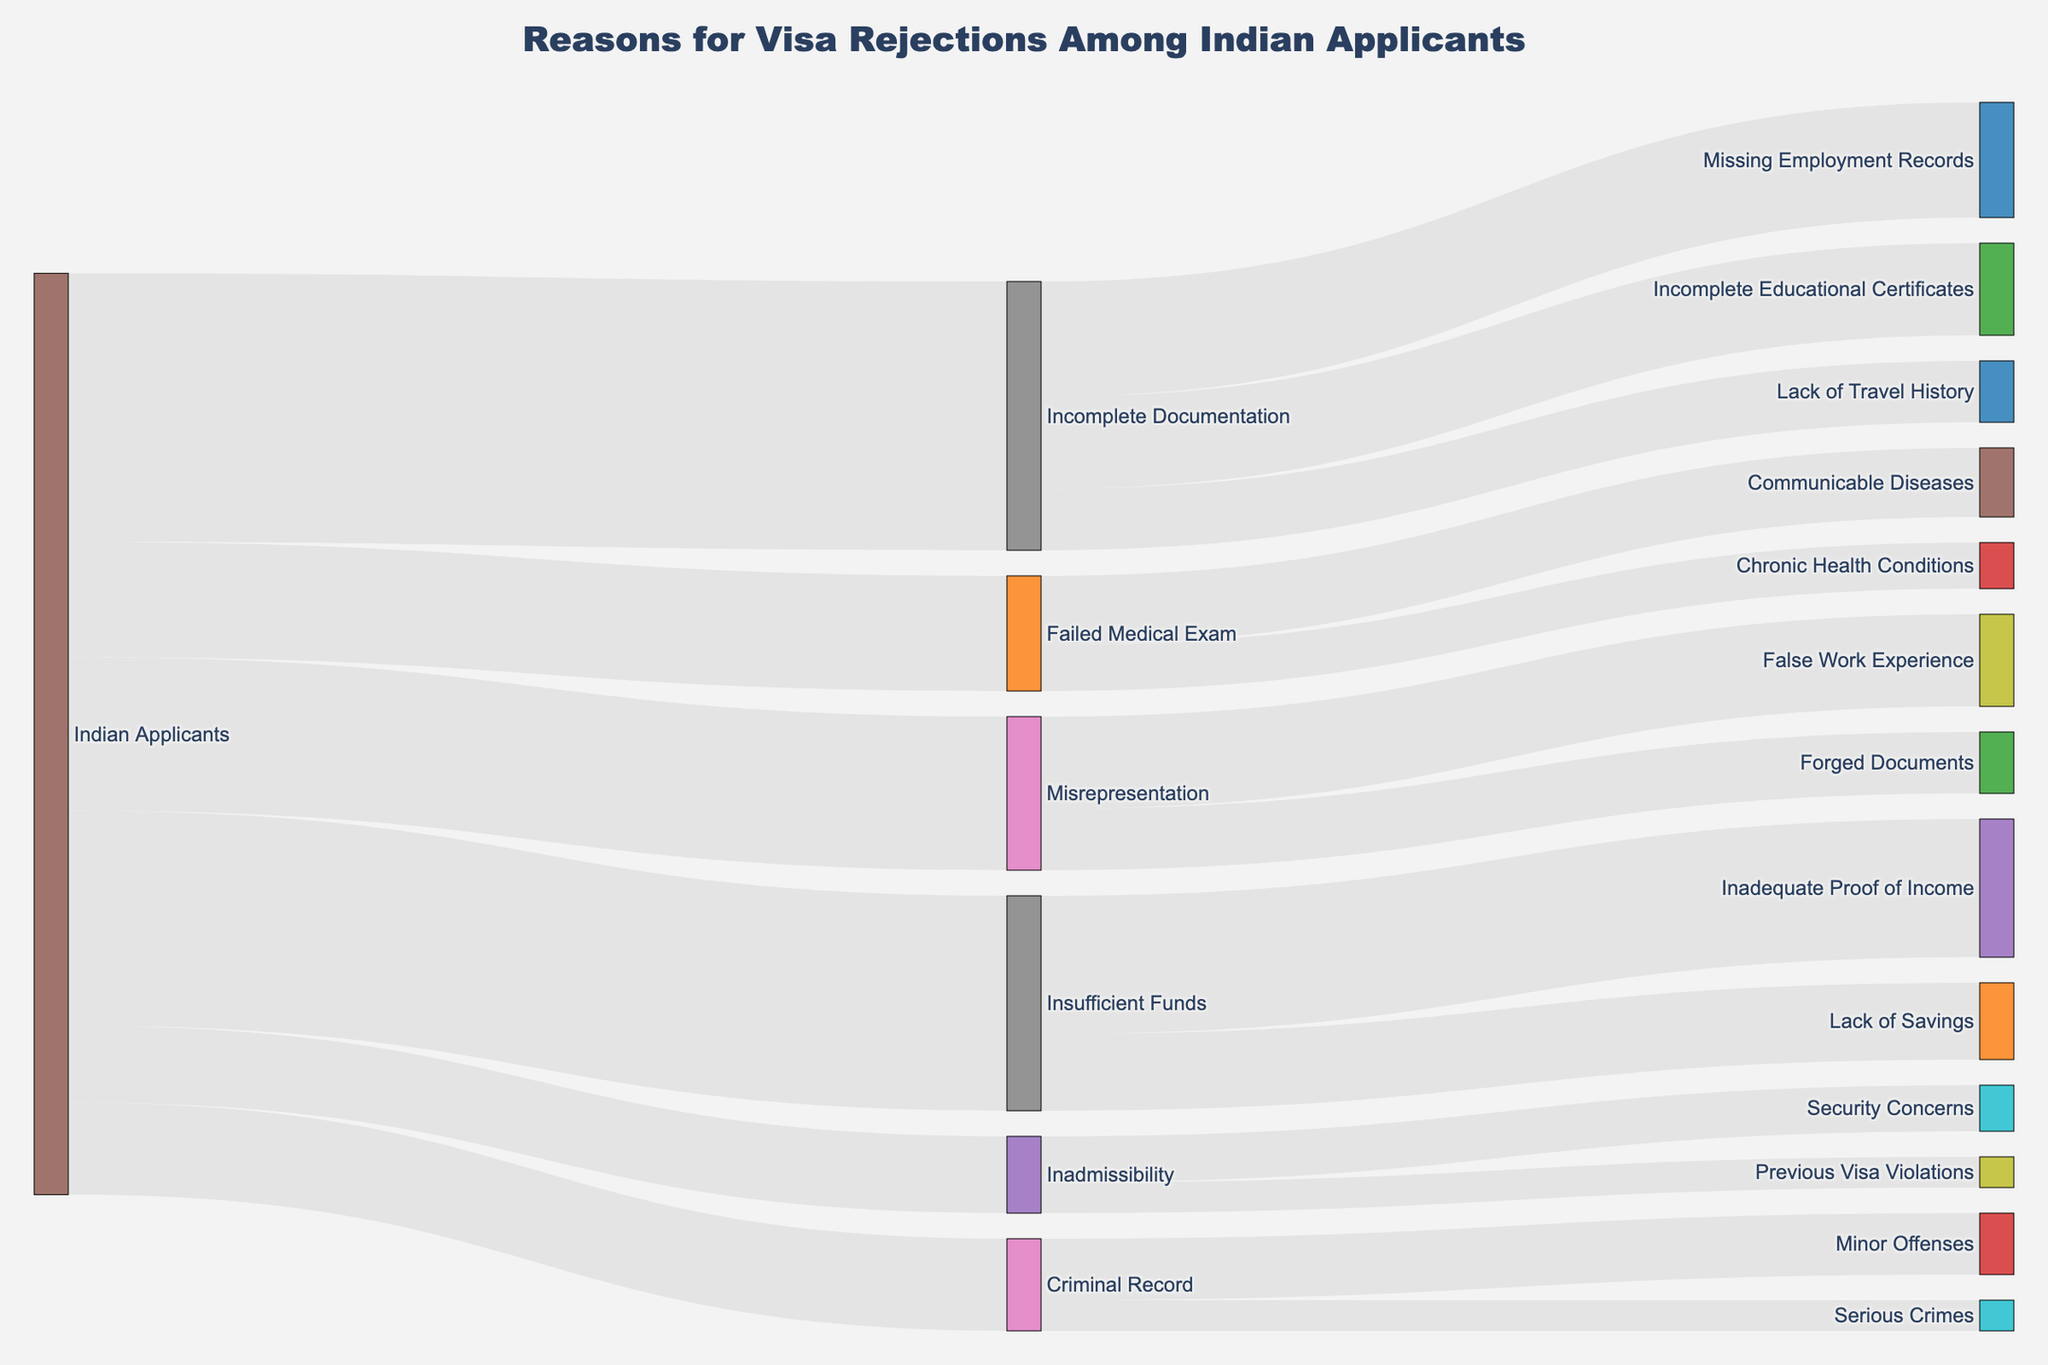What is the most common reason for visa rejections among Indian applicants? In the Sankey diagram, the node "Incomplete Documentation" has the highest value flow from "Indian Applicants" with a value of 350, indicating it is the top reason for rejections.
Answer: Incomplete Documentation How many visa rejections are attributed to insufficient funds? The Sankey diagram shows a flow from "Indian Applicants" to "Insufficient Funds" with a value of 280.
Answer: 280 What percentage of criminal record-related rejections are due to minor offenses? The diagram shows a flow from "Criminal Record" to "Minor Offenses" with a value of 80 out of a total 120 criminal record-related rejections. The percentage is calculated as (80 / 120) * 100.
Answer: 66.67% Which reason for insufficient funds has a higher count, inadequate proof of income or lack of savings? The flow for "Inadequate Proof of Income" is 180 and the flow for "Lack of Savings" is 100. Comparing these values, "Inadequate Proof of Income" is higher.
Answer: Inadequate Proof of Income How many visa rejections are due to failed medical exams? The Sankey diagram indicates a flow from "Indian Applicants" to "Failed Medical Exam" with a value of 150.
Answer: 150 Which specific ground within incomplete documentation has the smallest count? Within "Incomplete Documentation," "Lack of Travel History" has a value of 80, which is smaller than "Missing Employment Records" (150) and "Incomplete Educational Certificates" (120).
Answer: Lack of Travel History What is the total number of visa rejections attributed to misrepresentation? The flows from "Indian Applicants" to "Misrepresentation" add up to 200. For specifics, "False Work Experience" contributes 120 and "Forged Documents" contributes 80. Summing these gives a total of 200.
Answer: 200 Compare the number of rejections due to communicable diseases and chronic health conditions under failed medical exams. Which one is higher? The diagram shows flows of 90 for "Communicable Diseases" and 60 for "Chronic Health Conditions." "Communicable Diseases" is higher.
Answer: Communicable Diseases How many visa rejections are due to previous visa violations? The Sankey diagram shows a flow from "Inadmissibility" to "Previous Visa Violations" with a value of 40.
Answer: 40 What is the combined total of visa rejections due to criminal records and security concerns? Adding the values, "Criminal Record" contributes 120, and "Security Concerns" under "Inadmissibility" contributes 60. Together, they sum up to 120 + 60.
Answer: 180 